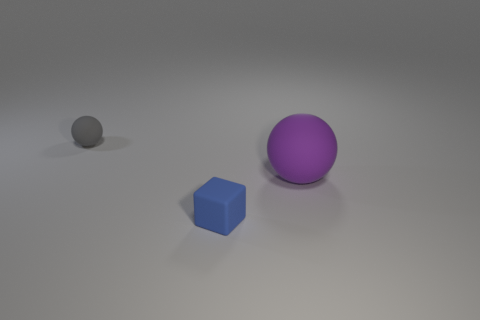Add 3 green cylinders. How many objects exist? 6 Subtract all blocks. How many objects are left? 2 Subtract all big green rubber objects. Subtract all big purple matte things. How many objects are left? 2 Add 3 small rubber objects. How many small rubber objects are left? 5 Add 3 purple spheres. How many purple spheres exist? 4 Subtract 1 blue blocks. How many objects are left? 2 